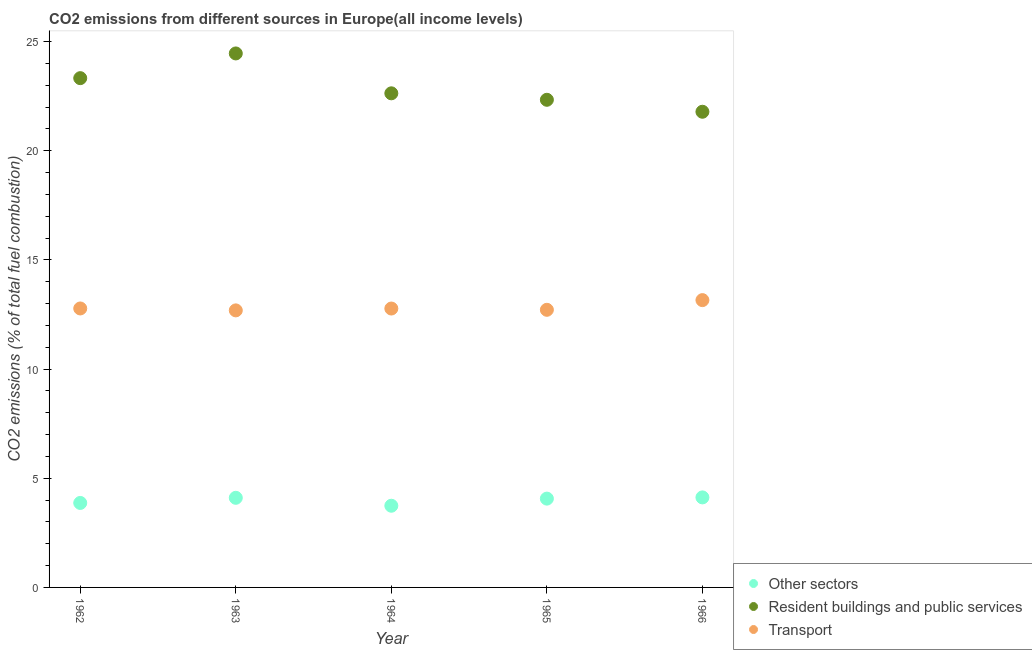How many different coloured dotlines are there?
Your response must be concise. 3. What is the percentage of co2 emissions from resident buildings and public services in 1966?
Give a very brief answer. 21.78. Across all years, what is the maximum percentage of co2 emissions from resident buildings and public services?
Provide a succinct answer. 24.45. Across all years, what is the minimum percentage of co2 emissions from resident buildings and public services?
Offer a very short reply. 21.78. In which year was the percentage of co2 emissions from resident buildings and public services maximum?
Your answer should be compact. 1963. In which year was the percentage of co2 emissions from resident buildings and public services minimum?
Your answer should be very brief. 1966. What is the total percentage of co2 emissions from transport in the graph?
Your answer should be very brief. 64.11. What is the difference between the percentage of co2 emissions from resident buildings and public services in 1962 and that in 1964?
Your answer should be very brief. 0.69. What is the difference between the percentage of co2 emissions from transport in 1966 and the percentage of co2 emissions from other sectors in 1965?
Keep it short and to the point. 9.09. What is the average percentage of co2 emissions from transport per year?
Ensure brevity in your answer.  12.82. In the year 1966, what is the difference between the percentage of co2 emissions from transport and percentage of co2 emissions from other sectors?
Ensure brevity in your answer.  9.03. What is the ratio of the percentage of co2 emissions from resident buildings and public services in 1962 to that in 1966?
Give a very brief answer. 1.07. Is the percentage of co2 emissions from other sectors in 1965 less than that in 1966?
Your answer should be compact. Yes. Is the difference between the percentage of co2 emissions from other sectors in 1965 and 1966 greater than the difference between the percentage of co2 emissions from transport in 1965 and 1966?
Your answer should be compact. Yes. What is the difference between the highest and the second highest percentage of co2 emissions from transport?
Offer a terse response. 0.38. What is the difference between the highest and the lowest percentage of co2 emissions from resident buildings and public services?
Your answer should be compact. 2.67. In how many years, is the percentage of co2 emissions from resident buildings and public services greater than the average percentage of co2 emissions from resident buildings and public services taken over all years?
Offer a very short reply. 2. Is the sum of the percentage of co2 emissions from transport in 1963 and 1964 greater than the maximum percentage of co2 emissions from resident buildings and public services across all years?
Provide a short and direct response. Yes. Is it the case that in every year, the sum of the percentage of co2 emissions from other sectors and percentage of co2 emissions from resident buildings and public services is greater than the percentage of co2 emissions from transport?
Your response must be concise. Yes. Does the percentage of co2 emissions from resident buildings and public services monotonically increase over the years?
Ensure brevity in your answer.  No. Is the percentage of co2 emissions from resident buildings and public services strictly greater than the percentage of co2 emissions from other sectors over the years?
Your response must be concise. Yes. How many years are there in the graph?
Provide a succinct answer. 5. What is the difference between two consecutive major ticks on the Y-axis?
Provide a succinct answer. 5. Does the graph contain any zero values?
Give a very brief answer. No. What is the title of the graph?
Give a very brief answer. CO2 emissions from different sources in Europe(all income levels). Does "Machinery" appear as one of the legend labels in the graph?
Keep it short and to the point. No. What is the label or title of the Y-axis?
Your answer should be very brief. CO2 emissions (% of total fuel combustion). What is the CO2 emissions (% of total fuel combustion) of Other sectors in 1962?
Provide a short and direct response. 3.87. What is the CO2 emissions (% of total fuel combustion) in Resident buildings and public services in 1962?
Offer a terse response. 23.32. What is the CO2 emissions (% of total fuel combustion) in Transport in 1962?
Ensure brevity in your answer.  12.78. What is the CO2 emissions (% of total fuel combustion) of Other sectors in 1963?
Your answer should be very brief. 4.1. What is the CO2 emissions (% of total fuel combustion) in Resident buildings and public services in 1963?
Offer a terse response. 24.45. What is the CO2 emissions (% of total fuel combustion) of Transport in 1963?
Offer a very short reply. 12.69. What is the CO2 emissions (% of total fuel combustion) of Other sectors in 1964?
Give a very brief answer. 3.74. What is the CO2 emissions (% of total fuel combustion) in Resident buildings and public services in 1964?
Ensure brevity in your answer.  22.63. What is the CO2 emissions (% of total fuel combustion) of Transport in 1964?
Offer a terse response. 12.77. What is the CO2 emissions (% of total fuel combustion) of Other sectors in 1965?
Your answer should be compact. 4.07. What is the CO2 emissions (% of total fuel combustion) of Resident buildings and public services in 1965?
Offer a very short reply. 22.33. What is the CO2 emissions (% of total fuel combustion) of Transport in 1965?
Your response must be concise. 12.71. What is the CO2 emissions (% of total fuel combustion) in Other sectors in 1966?
Make the answer very short. 4.12. What is the CO2 emissions (% of total fuel combustion) of Resident buildings and public services in 1966?
Your answer should be compact. 21.78. What is the CO2 emissions (% of total fuel combustion) of Transport in 1966?
Ensure brevity in your answer.  13.16. Across all years, what is the maximum CO2 emissions (% of total fuel combustion) in Other sectors?
Offer a very short reply. 4.12. Across all years, what is the maximum CO2 emissions (% of total fuel combustion) in Resident buildings and public services?
Offer a terse response. 24.45. Across all years, what is the maximum CO2 emissions (% of total fuel combustion) of Transport?
Your response must be concise. 13.16. Across all years, what is the minimum CO2 emissions (% of total fuel combustion) in Other sectors?
Offer a very short reply. 3.74. Across all years, what is the minimum CO2 emissions (% of total fuel combustion) in Resident buildings and public services?
Make the answer very short. 21.78. Across all years, what is the minimum CO2 emissions (% of total fuel combustion) in Transport?
Offer a very short reply. 12.69. What is the total CO2 emissions (% of total fuel combustion) in Other sectors in the graph?
Offer a terse response. 19.9. What is the total CO2 emissions (% of total fuel combustion) of Resident buildings and public services in the graph?
Your answer should be compact. 114.52. What is the total CO2 emissions (% of total fuel combustion) of Transport in the graph?
Your answer should be compact. 64.11. What is the difference between the CO2 emissions (% of total fuel combustion) of Other sectors in 1962 and that in 1963?
Your response must be concise. -0.23. What is the difference between the CO2 emissions (% of total fuel combustion) of Resident buildings and public services in 1962 and that in 1963?
Ensure brevity in your answer.  -1.13. What is the difference between the CO2 emissions (% of total fuel combustion) of Transport in 1962 and that in 1963?
Give a very brief answer. 0.09. What is the difference between the CO2 emissions (% of total fuel combustion) of Other sectors in 1962 and that in 1964?
Make the answer very short. 0.13. What is the difference between the CO2 emissions (% of total fuel combustion) in Resident buildings and public services in 1962 and that in 1964?
Your answer should be very brief. 0.69. What is the difference between the CO2 emissions (% of total fuel combustion) in Transport in 1962 and that in 1964?
Make the answer very short. 0. What is the difference between the CO2 emissions (% of total fuel combustion) of Other sectors in 1962 and that in 1965?
Your answer should be very brief. -0.2. What is the difference between the CO2 emissions (% of total fuel combustion) in Resident buildings and public services in 1962 and that in 1965?
Give a very brief answer. 0.99. What is the difference between the CO2 emissions (% of total fuel combustion) of Transport in 1962 and that in 1965?
Offer a very short reply. 0.06. What is the difference between the CO2 emissions (% of total fuel combustion) of Other sectors in 1962 and that in 1966?
Give a very brief answer. -0.25. What is the difference between the CO2 emissions (% of total fuel combustion) in Resident buildings and public services in 1962 and that in 1966?
Ensure brevity in your answer.  1.54. What is the difference between the CO2 emissions (% of total fuel combustion) of Transport in 1962 and that in 1966?
Your answer should be very brief. -0.38. What is the difference between the CO2 emissions (% of total fuel combustion) in Other sectors in 1963 and that in 1964?
Your answer should be very brief. 0.36. What is the difference between the CO2 emissions (% of total fuel combustion) in Resident buildings and public services in 1963 and that in 1964?
Offer a terse response. 1.83. What is the difference between the CO2 emissions (% of total fuel combustion) of Transport in 1963 and that in 1964?
Ensure brevity in your answer.  -0.08. What is the difference between the CO2 emissions (% of total fuel combustion) of Other sectors in 1963 and that in 1965?
Provide a succinct answer. 0.04. What is the difference between the CO2 emissions (% of total fuel combustion) in Resident buildings and public services in 1963 and that in 1965?
Give a very brief answer. 2.12. What is the difference between the CO2 emissions (% of total fuel combustion) of Transport in 1963 and that in 1965?
Your answer should be very brief. -0.03. What is the difference between the CO2 emissions (% of total fuel combustion) in Other sectors in 1963 and that in 1966?
Your answer should be compact. -0.02. What is the difference between the CO2 emissions (% of total fuel combustion) of Resident buildings and public services in 1963 and that in 1966?
Your answer should be compact. 2.67. What is the difference between the CO2 emissions (% of total fuel combustion) in Transport in 1963 and that in 1966?
Your response must be concise. -0.47. What is the difference between the CO2 emissions (% of total fuel combustion) of Other sectors in 1964 and that in 1965?
Keep it short and to the point. -0.33. What is the difference between the CO2 emissions (% of total fuel combustion) in Resident buildings and public services in 1964 and that in 1965?
Provide a short and direct response. 0.3. What is the difference between the CO2 emissions (% of total fuel combustion) of Transport in 1964 and that in 1965?
Give a very brief answer. 0.06. What is the difference between the CO2 emissions (% of total fuel combustion) in Other sectors in 1964 and that in 1966?
Your answer should be compact. -0.38. What is the difference between the CO2 emissions (% of total fuel combustion) in Resident buildings and public services in 1964 and that in 1966?
Ensure brevity in your answer.  0.84. What is the difference between the CO2 emissions (% of total fuel combustion) of Transport in 1964 and that in 1966?
Provide a short and direct response. -0.39. What is the difference between the CO2 emissions (% of total fuel combustion) of Other sectors in 1965 and that in 1966?
Provide a short and direct response. -0.06. What is the difference between the CO2 emissions (% of total fuel combustion) in Resident buildings and public services in 1965 and that in 1966?
Provide a succinct answer. 0.55. What is the difference between the CO2 emissions (% of total fuel combustion) in Transport in 1965 and that in 1966?
Your answer should be very brief. -0.44. What is the difference between the CO2 emissions (% of total fuel combustion) of Other sectors in 1962 and the CO2 emissions (% of total fuel combustion) of Resident buildings and public services in 1963?
Your response must be concise. -20.59. What is the difference between the CO2 emissions (% of total fuel combustion) of Other sectors in 1962 and the CO2 emissions (% of total fuel combustion) of Transport in 1963?
Provide a succinct answer. -8.82. What is the difference between the CO2 emissions (% of total fuel combustion) in Resident buildings and public services in 1962 and the CO2 emissions (% of total fuel combustion) in Transport in 1963?
Keep it short and to the point. 10.64. What is the difference between the CO2 emissions (% of total fuel combustion) of Other sectors in 1962 and the CO2 emissions (% of total fuel combustion) of Resident buildings and public services in 1964?
Provide a succinct answer. -18.76. What is the difference between the CO2 emissions (% of total fuel combustion) of Other sectors in 1962 and the CO2 emissions (% of total fuel combustion) of Transport in 1964?
Provide a short and direct response. -8.9. What is the difference between the CO2 emissions (% of total fuel combustion) of Resident buildings and public services in 1962 and the CO2 emissions (% of total fuel combustion) of Transport in 1964?
Make the answer very short. 10.55. What is the difference between the CO2 emissions (% of total fuel combustion) in Other sectors in 1962 and the CO2 emissions (% of total fuel combustion) in Resident buildings and public services in 1965?
Your answer should be very brief. -18.46. What is the difference between the CO2 emissions (% of total fuel combustion) in Other sectors in 1962 and the CO2 emissions (% of total fuel combustion) in Transport in 1965?
Ensure brevity in your answer.  -8.84. What is the difference between the CO2 emissions (% of total fuel combustion) of Resident buildings and public services in 1962 and the CO2 emissions (% of total fuel combustion) of Transport in 1965?
Your response must be concise. 10.61. What is the difference between the CO2 emissions (% of total fuel combustion) in Other sectors in 1962 and the CO2 emissions (% of total fuel combustion) in Resident buildings and public services in 1966?
Provide a short and direct response. -17.91. What is the difference between the CO2 emissions (% of total fuel combustion) in Other sectors in 1962 and the CO2 emissions (% of total fuel combustion) in Transport in 1966?
Your response must be concise. -9.29. What is the difference between the CO2 emissions (% of total fuel combustion) of Resident buildings and public services in 1962 and the CO2 emissions (% of total fuel combustion) of Transport in 1966?
Make the answer very short. 10.17. What is the difference between the CO2 emissions (% of total fuel combustion) of Other sectors in 1963 and the CO2 emissions (% of total fuel combustion) of Resident buildings and public services in 1964?
Your answer should be very brief. -18.52. What is the difference between the CO2 emissions (% of total fuel combustion) of Other sectors in 1963 and the CO2 emissions (% of total fuel combustion) of Transport in 1964?
Keep it short and to the point. -8.67. What is the difference between the CO2 emissions (% of total fuel combustion) of Resident buildings and public services in 1963 and the CO2 emissions (% of total fuel combustion) of Transport in 1964?
Ensure brevity in your answer.  11.68. What is the difference between the CO2 emissions (% of total fuel combustion) in Other sectors in 1963 and the CO2 emissions (% of total fuel combustion) in Resident buildings and public services in 1965?
Provide a short and direct response. -18.23. What is the difference between the CO2 emissions (% of total fuel combustion) in Other sectors in 1963 and the CO2 emissions (% of total fuel combustion) in Transport in 1965?
Offer a very short reply. -8.61. What is the difference between the CO2 emissions (% of total fuel combustion) in Resident buildings and public services in 1963 and the CO2 emissions (% of total fuel combustion) in Transport in 1965?
Offer a very short reply. 11.74. What is the difference between the CO2 emissions (% of total fuel combustion) in Other sectors in 1963 and the CO2 emissions (% of total fuel combustion) in Resident buildings and public services in 1966?
Your answer should be compact. -17.68. What is the difference between the CO2 emissions (% of total fuel combustion) of Other sectors in 1963 and the CO2 emissions (% of total fuel combustion) of Transport in 1966?
Your answer should be very brief. -9.05. What is the difference between the CO2 emissions (% of total fuel combustion) of Resident buildings and public services in 1963 and the CO2 emissions (% of total fuel combustion) of Transport in 1966?
Your answer should be very brief. 11.3. What is the difference between the CO2 emissions (% of total fuel combustion) of Other sectors in 1964 and the CO2 emissions (% of total fuel combustion) of Resident buildings and public services in 1965?
Ensure brevity in your answer.  -18.59. What is the difference between the CO2 emissions (% of total fuel combustion) of Other sectors in 1964 and the CO2 emissions (% of total fuel combustion) of Transport in 1965?
Offer a very short reply. -8.97. What is the difference between the CO2 emissions (% of total fuel combustion) in Resident buildings and public services in 1964 and the CO2 emissions (% of total fuel combustion) in Transport in 1965?
Your answer should be compact. 9.91. What is the difference between the CO2 emissions (% of total fuel combustion) in Other sectors in 1964 and the CO2 emissions (% of total fuel combustion) in Resident buildings and public services in 1966?
Offer a very short reply. -18.04. What is the difference between the CO2 emissions (% of total fuel combustion) of Other sectors in 1964 and the CO2 emissions (% of total fuel combustion) of Transport in 1966?
Provide a succinct answer. -9.42. What is the difference between the CO2 emissions (% of total fuel combustion) in Resident buildings and public services in 1964 and the CO2 emissions (% of total fuel combustion) in Transport in 1966?
Offer a terse response. 9.47. What is the difference between the CO2 emissions (% of total fuel combustion) in Other sectors in 1965 and the CO2 emissions (% of total fuel combustion) in Resident buildings and public services in 1966?
Your response must be concise. -17.72. What is the difference between the CO2 emissions (% of total fuel combustion) of Other sectors in 1965 and the CO2 emissions (% of total fuel combustion) of Transport in 1966?
Provide a succinct answer. -9.09. What is the difference between the CO2 emissions (% of total fuel combustion) in Resident buildings and public services in 1965 and the CO2 emissions (% of total fuel combustion) in Transport in 1966?
Provide a short and direct response. 9.17. What is the average CO2 emissions (% of total fuel combustion) in Other sectors per year?
Provide a short and direct response. 3.98. What is the average CO2 emissions (% of total fuel combustion) in Resident buildings and public services per year?
Your answer should be very brief. 22.9. What is the average CO2 emissions (% of total fuel combustion) of Transport per year?
Offer a terse response. 12.82. In the year 1962, what is the difference between the CO2 emissions (% of total fuel combustion) of Other sectors and CO2 emissions (% of total fuel combustion) of Resident buildings and public services?
Keep it short and to the point. -19.45. In the year 1962, what is the difference between the CO2 emissions (% of total fuel combustion) of Other sectors and CO2 emissions (% of total fuel combustion) of Transport?
Provide a succinct answer. -8.91. In the year 1962, what is the difference between the CO2 emissions (% of total fuel combustion) in Resident buildings and public services and CO2 emissions (% of total fuel combustion) in Transport?
Provide a succinct answer. 10.55. In the year 1963, what is the difference between the CO2 emissions (% of total fuel combustion) in Other sectors and CO2 emissions (% of total fuel combustion) in Resident buildings and public services?
Your answer should be compact. -20.35. In the year 1963, what is the difference between the CO2 emissions (% of total fuel combustion) of Other sectors and CO2 emissions (% of total fuel combustion) of Transport?
Offer a very short reply. -8.58. In the year 1963, what is the difference between the CO2 emissions (% of total fuel combustion) in Resident buildings and public services and CO2 emissions (% of total fuel combustion) in Transport?
Provide a succinct answer. 11.77. In the year 1964, what is the difference between the CO2 emissions (% of total fuel combustion) of Other sectors and CO2 emissions (% of total fuel combustion) of Resident buildings and public services?
Your answer should be compact. -18.89. In the year 1964, what is the difference between the CO2 emissions (% of total fuel combustion) of Other sectors and CO2 emissions (% of total fuel combustion) of Transport?
Your response must be concise. -9.03. In the year 1964, what is the difference between the CO2 emissions (% of total fuel combustion) in Resident buildings and public services and CO2 emissions (% of total fuel combustion) in Transport?
Your answer should be very brief. 9.86. In the year 1965, what is the difference between the CO2 emissions (% of total fuel combustion) of Other sectors and CO2 emissions (% of total fuel combustion) of Resident buildings and public services?
Offer a terse response. -18.27. In the year 1965, what is the difference between the CO2 emissions (% of total fuel combustion) in Other sectors and CO2 emissions (% of total fuel combustion) in Transport?
Give a very brief answer. -8.65. In the year 1965, what is the difference between the CO2 emissions (% of total fuel combustion) of Resident buildings and public services and CO2 emissions (% of total fuel combustion) of Transport?
Offer a very short reply. 9.62. In the year 1966, what is the difference between the CO2 emissions (% of total fuel combustion) in Other sectors and CO2 emissions (% of total fuel combustion) in Resident buildings and public services?
Make the answer very short. -17.66. In the year 1966, what is the difference between the CO2 emissions (% of total fuel combustion) of Other sectors and CO2 emissions (% of total fuel combustion) of Transport?
Keep it short and to the point. -9.03. In the year 1966, what is the difference between the CO2 emissions (% of total fuel combustion) in Resident buildings and public services and CO2 emissions (% of total fuel combustion) in Transport?
Your answer should be very brief. 8.63. What is the ratio of the CO2 emissions (% of total fuel combustion) of Other sectors in 1962 to that in 1963?
Offer a terse response. 0.94. What is the ratio of the CO2 emissions (% of total fuel combustion) of Resident buildings and public services in 1962 to that in 1963?
Your answer should be very brief. 0.95. What is the ratio of the CO2 emissions (% of total fuel combustion) in Transport in 1962 to that in 1963?
Keep it short and to the point. 1.01. What is the ratio of the CO2 emissions (% of total fuel combustion) in Other sectors in 1962 to that in 1964?
Offer a very short reply. 1.03. What is the ratio of the CO2 emissions (% of total fuel combustion) in Resident buildings and public services in 1962 to that in 1964?
Your response must be concise. 1.03. What is the ratio of the CO2 emissions (% of total fuel combustion) in Other sectors in 1962 to that in 1965?
Give a very brief answer. 0.95. What is the ratio of the CO2 emissions (% of total fuel combustion) of Resident buildings and public services in 1962 to that in 1965?
Your answer should be very brief. 1.04. What is the ratio of the CO2 emissions (% of total fuel combustion) in Other sectors in 1962 to that in 1966?
Provide a short and direct response. 0.94. What is the ratio of the CO2 emissions (% of total fuel combustion) of Resident buildings and public services in 1962 to that in 1966?
Give a very brief answer. 1.07. What is the ratio of the CO2 emissions (% of total fuel combustion) in Transport in 1962 to that in 1966?
Your answer should be very brief. 0.97. What is the ratio of the CO2 emissions (% of total fuel combustion) of Other sectors in 1963 to that in 1964?
Offer a very short reply. 1.1. What is the ratio of the CO2 emissions (% of total fuel combustion) in Resident buildings and public services in 1963 to that in 1964?
Give a very brief answer. 1.08. What is the ratio of the CO2 emissions (% of total fuel combustion) of Transport in 1963 to that in 1964?
Your answer should be compact. 0.99. What is the ratio of the CO2 emissions (% of total fuel combustion) of Other sectors in 1963 to that in 1965?
Offer a terse response. 1.01. What is the ratio of the CO2 emissions (% of total fuel combustion) of Resident buildings and public services in 1963 to that in 1965?
Offer a very short reply. 1.09. What is the ratio of the CO2 emissions (% of total fuel combustion) in Transport in 1963 to that in 1965?
Ensure brevity in your answer.  1. What is the ratio of the CO2 emissions (% of total fuel combustion) in Other sectors in 1963 to that in 1966?
Give a very brief answer. 1. What is the ratio of the CO2 emissions (% of total fuel combustion) of Resident buildings and public services in 1963 to that in 1966?
Give a very brief answer. 1.12. What is the ratio of the CO2 emissions (% of total fuel combustion) of Transport in 1963 to that in 1966?
Your answer should be very brief. 0.96. What is the ratio of the CO2 emissions (% of total fuel combustion) in Other sectors in 1964 to that in 1965?
Your answer should be compact. 0.92. What is the ratio of the CO2 emissions (% of total fuel combustion) of Resident buildings and public services in 1964 to that in 1965?
Ensure brevity in your answer.  1.01. What is the ratio of the CO2 emissions (% of total fuel combustion) of Other sectors in 1964 to that in 1966?
Provide a short and direct response. 0.91. What is the ratio of the CO2 emissions (% of total fuel combustion) of Resident buildings and public services in 1964 to that in 1966?
Ensure brevity in your answer.  1.04. What is the ratio of the CO2 emissions (% of total fuel combustion) in Transport in 1964 to that in 1966?
Provide a short and direct response. 0.97. What is the ratio of the CO2 emissions (% of total fuel combustion) in Other sectors in 1965 to that in 1966?
Offer a very short reply. 0.99. What is the ratio of the CO2 emissions (% of total fuel combustion) in Resident buildings and public services in 1965 to that in 1966?
Offer a very short reply. 1.03. What is the ratio of the CO2 emissions (% of total fuel combustion) in Transport in 1965 to that in 1966?
Your answer should be compact. 0.97. What is the difference between the highest and the second highest CO2 emissions (% of total fuel combustion) in Other sectors?
Give a very brief answer. 0.02. What is the difference between the highest and the second highest CO2 emissions (% of total fuel combustion) in Resident buildings and public services?
Your answer should be compact. 1.13. What is the difference between the highest and the second highest CO2 emissions (% of total fuel combustion) in Transport?
Ensure brevity in your answer.  0.38. What is the difference between the highest and the lowest CO2 emissions (% of total fuel combustion) of Other sectors?
Provide a succinct answer. 0.38. What is the difference between the highest and the lowest CO2 emissions (% of total fuel combustion) of Resident buildings and public services?
Give a very brief answer. 2.67. What is the difference between the highest and the lowest CO2 emissions (% of total fuel combustion) in Transport?
Your answer should be compact. 0.47. 